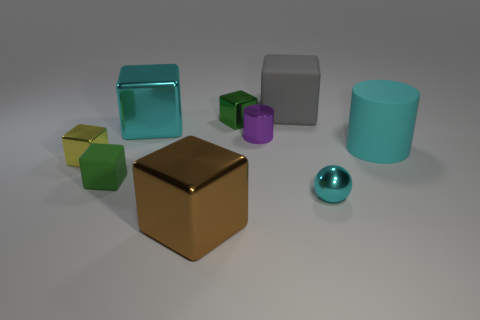What is the shape of the gray rubber object?
Your answer should be very brief. Cube. What material is the gray thing that is the same shape as the tiny yellow metal thing?
Your answer should be very brief. Rubber. How many green metallic things are the same size as the sphere?
Keep it short and to the point. 1. There is a matte thing left of the big matte block; are there any large cyan rubber objects in front of it?
Make the answer very short. No. What number of cyan things are either tiny cylinders or matte objects?
Provide a succinct answer. 1. What color is the metal cylinder?
Ensure brevity in your answer.  Purple. There is a brown block that is made of the same material as the yellow object; what is its size?
Ensure brevity in your answer.  Large. How many yellow metallic things are the same shape as the big cyan matte thing?
Offer a terse response. 0. How big is the rubber cube behind the small block on the left side of the green matte cube?
Provide a short and direct response. Large. What is the material of the brown thing that is the same size as the cyan rubber object?
Provide a succinct answer. Metal. 